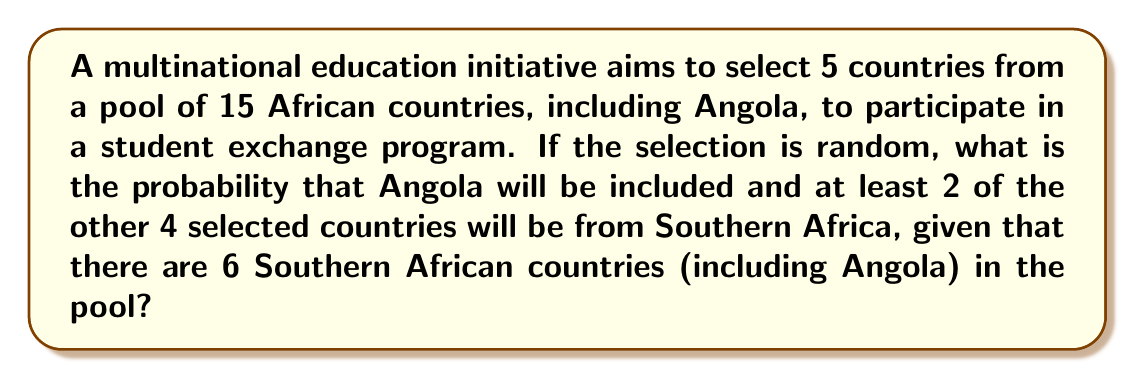Could you help me with this problem? Let's approach this step-by-step:

1) First, we know Angola must be selected, so we need to choose 4 more countries from the remaining 14.

2) We need at least 2 more Southern African countries. There are 5 other Southern African countries in the pool (6 total - Angola).

3) We can have 2, 3, or 4 other Southern African countries. Let's calculate each case:

   Case 1: 2 other Southern African countries and 2 non-Southern African countries
   Case 2: 3 other Southern African countries and 1 non-Southern African country
   Case 3: 4 other Southern African countries

4) Let's calculate the number of ways for each case:

   Case 1: $\binom{5}{2} \times \binom{9}{2}$
   Case 2: $\binom{5}{3} \times \binom{9}{1}$
   Case 3: $\binom{5}{4}$

5) Total favorable outcomes:
   $$\binom{5}{2} \times \binom{9}{2} + \binom{5}{3} \times \binom{9}{1} + \binom{5}{4}$$
   $$= 10 \times 36 + 10 \times 9 + 5 = 360 + 90 + 5 = 455$$

6) Total possible outcomes (choosing 4 from 14):
   $$\binom{14}{4} = 1001$$

7) Probability:
   $$P = \frac{455}{1001} \approx 0.4545$$
Answer: $\frac{455}{1001} \approx 0.4545$ 